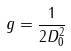<formula> <loc_0><loc_0><loc_500><loc_500>g = \frac { 1 } { 2 D _ { 0 } ^ { 2 } }</formula> 